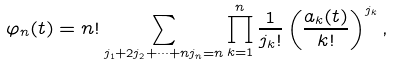Convert formula to latex. <formula><loc_0><loc_0><loc_500><loc_500>\varphi _ { n } ( t ) = n ! \sum _ { j _ { 1 } + 2 j _ { 2 } + \dots + n j _ { n } = n } \prod _ { k = 1 } ^ { n } \frac { 1 } { j _ { k } ! } \left ( \frac { a _ { k } ( t ) } { k ! } \right ) ^ { j _ { k } } ,</formula> 